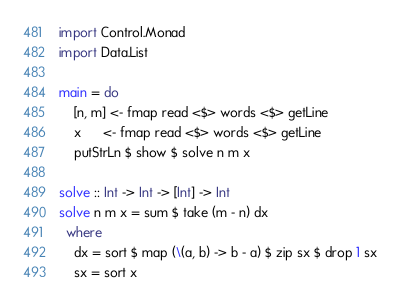Convert code to text. <code><loc_0><loc_0><loc_500><loc_500><_Haskell_>import Control.Monad
import Data.List

main = do
    [n, m] <- fmap read <$> words <$> getLine
    x      <- fmap read <$> words <$> getLine
    putStrLn $ show $ solve n m x

solve :: Int -> Int -> [Int] -> Int
solve n m x = sum $ take (m - n) dx
  where
    dx = sort $ map (\(a, b) -> b - a) $ zip sx $ drop 1 sx
    sx = sort x</code> 